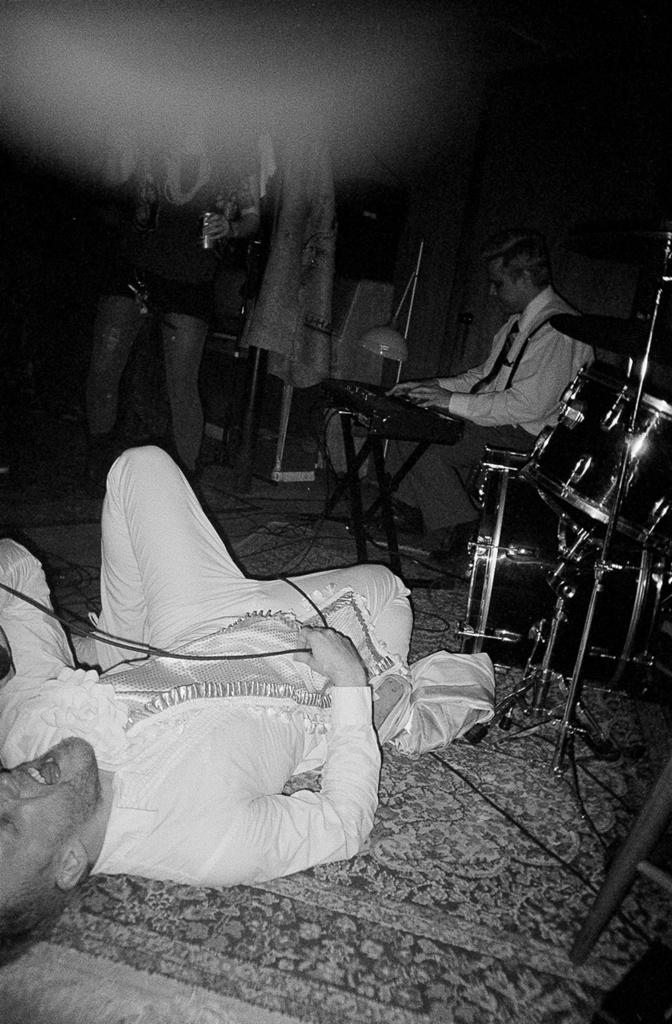What is the position of the man in the image? There is a man lying on the floor in the image. What is the man on the floor doing? The question does not specify which man, but there is a man playing the piano in the image. What musical instrument is on the right side of the image? There is a drum set on the right side of the image. How many hooks can be seen hanging from the ceiling in the image? There are no hooks visible in the image. What type of stem is growing out of the drum set in the image? There is no stem growing out of the drum set in the image. 